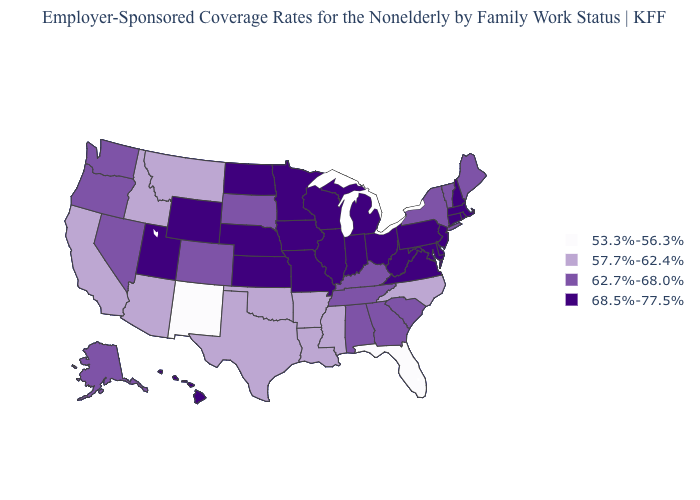Name the states that have a value in the range 68.5%-77.5%?
Answer briefly. Connecticut, Delaware, Hawaii, Illinois, Indiana, Iowa, Kansas, Maryland, Massachusetts, Michigan, Minnesota, Missouri, Nebraska, New Hampshire, New Jersey, North Dakota, Ohio, Pennsylvania, Rhode Island, Utah, Virginia, West Virginia, Wisconsin, Wyoming. What is the value of Wisconsin?
Concise answer only. 68.5%-77.5%. Does the map have missing data?
Concise answer only. No. Among the states that border Maryland , which have the highest value?
Quick response, please. Delaware, Pennsylvania, Virginia, West Virginia. Name the states that have a value in the range 68.5%-77.5%?
Write a very short answer. Connecticut, Delaware, Hawaii, Illinois, Indiana, Iowa, Kansas, Maryland, Massachusetts, Michigan, Minnesota, Missouri, Nebraska, New Hampshire, New Jersey, North Dakota, Ohio, Pennsylvania, Rhode Island, Utah, Virginia, West Virginia, Wisconsin, Wyoming. Name the states that have a value in the range 57.7%-62.4%?
Keep it brief. Arizona, Arkansas, California, Idaho, Louisiana, Mississippi, Montana, North Carolina, Oklahoma, Texas. Is the legend a continuous bar?
Give a very brief answer. No. Does West Virginia have a higher value than Maryland?
Short answer required. No. Among the states that border California , which have the lowest value?
Concise answer only. Arizona. Does Virginia have the lowest value in the South?
Concise answer only. No. Does Connecticut have the highest value in the USA?
Concise answer only. Yes. Which states have the highest value in the USA?
Keep it brief. Connecticut, Delaware, Hawaii, Illinois, Indiana, Iowa, Kansas, Maryland, Massachusetts, Michigan, Minnesota, Missouri, Nebraska, New Hampshire, New Jersey, North Dakota, Ohio, Pennsylvania, Rhode Island, Utah, Virginia, West Virginia, Wisconsin, Wyoming. What is the value of South Dakota?
Keep it brief. 62.7%-68.0%. Among the states that border New Hampshire , which have the lowest value?
Give a very brief answer. Maine, Vermont. Does Vermont have a higher value than Utah?
Keep it brief. No. 